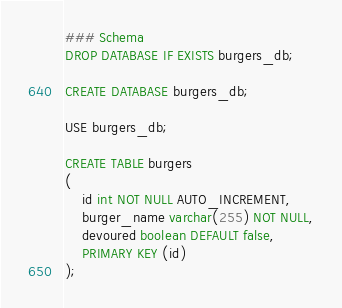Convert code to text. <code><loc_0><loc_0><loc_500><loc_500><_SQL_>### Schema
DROP DATABASE IF EXISTS burgers_db;

CREATE DATABASE burgers_db;

USE burgers_db;

CREATE TABLE burgers
(
	id int NOT NULL AUTO_INCREMENT,
	burger_name varchar(255) NOT NULL,
    devoured boolean DEFAULT false,
	PRIMARY KEY (id)
);</code> 